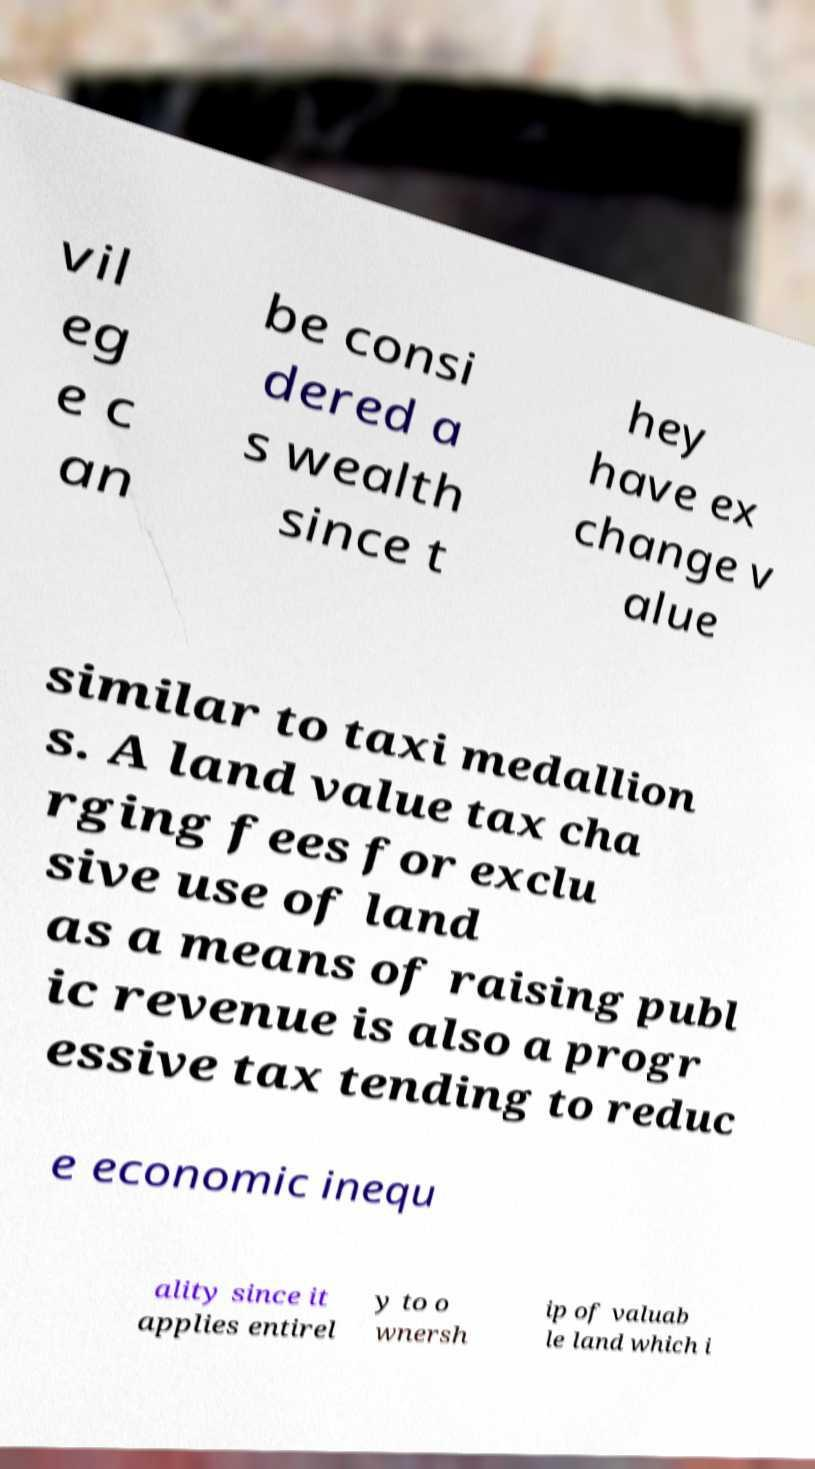Please identify and transcribe the text found in this image. vil eg e c an be consi dered a s wealth since t hey have ex change v alue similar to taxi medallion s. A land value tax cha rging fees for exclu sive use of land as a means of raising publ ic revenue is also a progr essive tax tending to reduc e economic inequ ality since it applies entirel y to o wnersh ip of valuab le land which i 